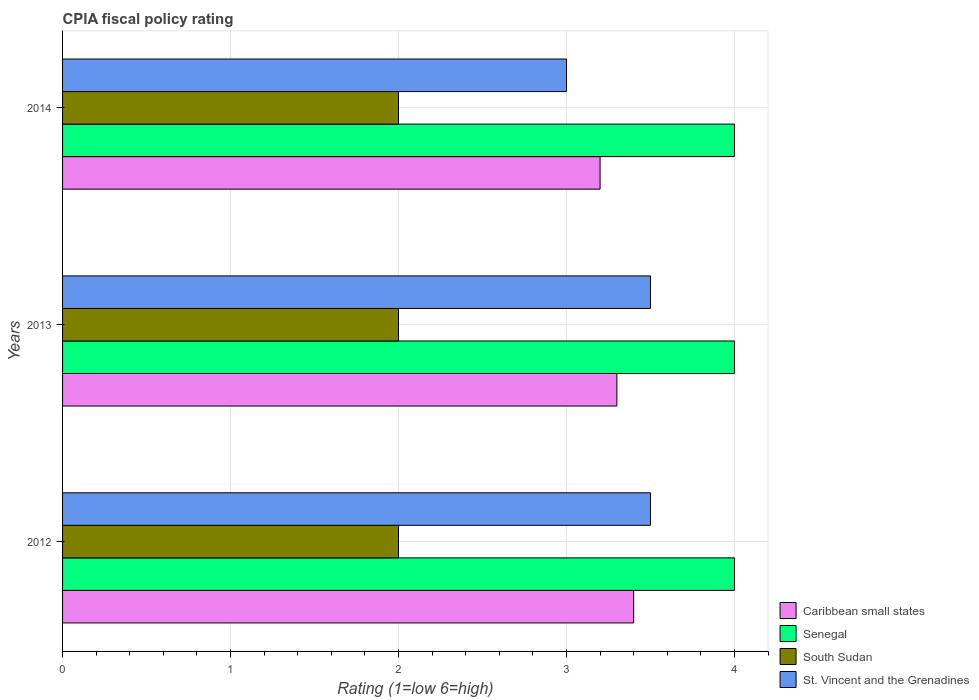Are the number of bars on each tick of the Y-axis equal?
Offer a terse response. Yes. What is the CPIA rating in St. Vincent and the Grenadines in 2013?
Your answer should be very brief. 3.5. Across all years, what is the minimum CPIA rating in St. Vincent and the Grenadines?
Your response must be concise. 3. In which year was the CPIA rating in St. Vincent and the Grenadines minimum?
Keep it short and to the point. 2014. What is the total CPIA rating in Caribbean small states in the graph?
Ensure brevity in your answer.  9.9. What is the difference between the CPIA rating in South Sudan in 2012 and that in 2013?
Offer a very short reply. 0. What is the average CPIA rating in Caribbean small states per year?
Give a very brief answer. 3.3. In the year 2014, what is the difference between the CPIA rating in Senegal and CPIA rating in Caribbean small states?
Make the answer very short. 0.8. In how many years, is the CPIA rating in Caribbean small states greater than 1.6 ?
Offer a terse response. 3. What is the difference between the highest and the second highest CPIA rating in South Sudan?
Give a very brief answer. 0. What is the difference between the highest and the lowest CPIA rating in St. Vincent and the Grenadines?
Keep it short and to the point. 0.5. In how many years, is the CPIA rating in Caribbean small states greater than the average CPIA rating in Caribbean small states taken over all years?
Make the answer very short. 2. Is the sum of the CPIA rating in St. Vincent and the Grenadines in 2012 and 2014 greater than the maximum CPIA rating in Caribbean small states across all years?
Your answer should be very brief. Yes. Is it the case that in every year, the sum of the CPIA rating in St. Vincent and the Grenadines and CPIA rating in Caribbean small states is greater than the sum of CPIA rating in South Sudan and CPIA rating in Senegal?
Make the answer very short. No. What does the 1st bar from the top in 2012 represents?
Give a very brief answer. St. Vincent and the Grenadines. What does the 4th bar from the bottom in 2013 represents?
Your response must be concise. St. Vincent and the Grenadines. How many bars are there?
Offer a terse response. 12. How many years are there in the graph?
Give a very brief answer. 3. Are the values on the major ticks of X-axis written in scientific E-notation?
Your answer should be compact. No. What is the title of the graph?
Your answer should be very brief. CPIA fiscal policy rating. Does "Cyprus" appear as one of the legend labels in the graph?
Keep it short and to the point. No. What is the label or title of the X-axis?
Make the answer very short. Rating (1=low 6=high). What is the Rating (1=low 6=high) of South Sudan in 2012?
Offer a very short reply. 2. What is the Rating (1=low 6=high) in St. Vincent and the Grenadines in 2012?
Keep it short and to the point. 3.5. What is the Rating (1=low 6=high) in Caribbean small states in 2013?
Your response must be concise. 3.3. What is the Rating (1=low 6=high) in Senegal in 2013?
Give a very brief answer. 4. What is the Rating (1=low 6=high) in South Sudan in 2013?
Your response must be concise. 2. Across all years, what is the maximum Rating (1=low 6=high) in Senegal?
Give a very brief answer. 4. Across all years, what is the maximum Rating (1=low 6=high) of St. Vincent and the Grenadines?
Your answer should be compact. 3.5. Across all years, what is the minimum Rating (1=low 6=high) of Senegal?
Give a very brief answer. 4. Across all years, what is the minimum Rating (1=low 6=high) in South Sudan?
Ensure brevity in your answer.  2. What is the total Rating (1=low 6=high) of Caribbean small states in the graph?
Make the answer very short. 9.9. What is the difference between the Rating (1=low 6=high) of St. Vincent and the Grenadines in 2012 and that in 2013?
Your response must be concise. 0. What is the difference between the Rating (1=low 6=high) of Caribbean small states in 2012 and that in 2014?
Your answer should be compact. 0.2. What is the difference between the Rating (1=low 6=high) of Senegal in 2012 and that in 2014?
Ensure brevity in your answer.  0. What is the difference between the Rating (1=low 6=high) in Caribbean small states in 2013 and that in 2014?
Your answer should be compact. 0.1. What is the difference between the Rating (1=low 6=high) of Senegal in 2013 and that in 2014?
Keep it short and to the point. 0. What is the difference between the Rating (1=low 6=high) in South Sudan in 2013 and that in 2014?
Ensure brevity in your answer.  0. What is the difference between the Rating (1=low 6=high) in St. Vincent and the Grenadines in 2013 and that in 2014?
Provide a succinct answer. 0.5. What is the difference between the Rating (1=low 6=high) in Caribbean small states in 2012 and the Rating (1=low 6=high) in South Sudan in 2013?
Ensure brevity in your answer.  1.4. What is the difference between the Rating (1=low 6=high) in Caribbean small states in 2012 and the Rating (1=low 6=high) in St. Vincent and the Grenadines in 2013?
Offer a terse response. -0.1. What is the difference between the Rating (1=low 6=high) in Senegal in 2012 and the Rating (1=low 6=high) in South Sudan in 2013?
Provide a succinct answer. 2. What is the difference between the Rating (1=low 6=high) of South Sudan in 2012 and the Rating (1=low 6=high) of St. Vincent and the Grenadines in 2013?
Give a very brief answer. -1.5. What is the difference between the Rating (1=low 6=high) in Caribbean small states in 2012 and the Rating (1=low 6=high) in Senegal in 2014?
Offer a terse response. -0.6. What is the difference between the Rating (1=low 6=high) in Senegal in 2012 and the Rating (1=low 6=high) in South Sudan in 2014?
Provide a succinct answer. 2. What is the difference between the Rating (1=low 6=high) in Caribbean small states in 2013 and the Rating (1=low 6=high) in St. Vincent and the Grenadines in 2014?
Keep it short and to the point. 0.3. What is the difference between the Rating (1=low 6=high) in Senegal in 2013 and the Rating (1=low 6=high) in South Sudan in 2014?
Provide a short and direct response. 2. What is the average Rating (1=low 6=high) of Caribbean small states per year?
Your answer should be compact. 3.3. What is the average Rating (1=low 6=high) in Senegal per year?
Make the answer very short. 4. What is the average Rating (1=low 6=high) in South Sudan per year?
Provide a succinct answer. 2. What is the average Rating (1=low 6=high) of St. Vincent and the Grenadines per year?
Your answer should be compact. 3.33. In the year 2012, what is the difference between the Rating (1=low 6=high) of Caribbean small states and Rating (1=low 6=high) of Senegal?
Offer a very short reply. -0.6. In the year 2012, what is the difference between the Rating (1=low 6=high) in Caribbean small states and Rating (1=low 6=high) in South Sudan?
Give a very brief answer. 1.4. In the year 2012, what is the difference between the Rating (1=low 6=high) in Senegal and Rating (1=low 6=high) in South Sudan?
Offer a terse response. 2. In the year 2012, what is the difference between the Rating (1=low 6=high) in Senegal and Rating (1=low 6=high) in St. Vincent and the Grenadines?
Provide a short and direct response. 0.5. In the year 2013, what is the difference between the Rating (1=low 6=high) in Senegal and Rating (1=low 6=high) in South Sudan?
Offer a terse response. 2. In the year 2013, what is the difference between the Rating (1=low 6=high) of South Sudan and Rating (1=low 6=high) of St. Vincent and the Grenadines?
Make the answer very short. -1.5. In the year 2014, what is the difference between the Rating (1=low 6=high) in Caribbean small states and Rating (1=low 6=high) in South Sudan?
Your answer should be compact. 1.2. In the year 2014, what is the difference between the Rating (1=low 6=high) of Caribbean small states and Rating (1=low 6=high) of St. Vincent and the Grenadines?
Provide a succinct answer. 0.2. In the year 2014, what is the difference between the Rating (1=low 6=high) of Senegal and Rating (1=low 6=high) of St. Vincent and the Grenadines?
Offer a terse response. 1. In the year 2014, what is the difference between the Rating (1=low 6=high) in South Sudan and Rating (1=low 6=high) in St. Vincent and the Grenadines?
Offer a very short reply. -1. What is the ratio of the Rating (1=low 6=high) in Caribbean small states in 2012 to that in 2013?
Offer a terse response. 1.03. What is the ratio of the Rating (1=low 6=high) in South Sudan in 2012 to that in 2013?
Offer a very short reply. 1. What is the ratio of the Rating (1=low 6=high) in Senegal in 2012 to that in 2014?
Make the answer very short. 1. What is the ratio of the Rating (1=low 6=high) of South Sudan in 2012 to that in 2014?
Your response must be concise. 1. What is the ratio of the Rating (1=low 6=high) in St. Vincent and the Grenadines in 2012 to that in 2014?
Keep it short and to the point. 1.17. What is the ratio of the Rating (1=low 6=high) of Caribbean small states in 2013 to that in 2014?
Your response must be concise. 1.03. What is the ratio of the Rating (1=low 6=high) in Senegal in 2013 to that in 2014?
Your answer should be compact. 1. What is the ratio of the Rating (1=low 6=high) in St. Vincent and the Grenadines in 2013 to that in 2014?
Ensure brevity in your answer.  1.17. What is the difference between the highest and the second highest Rating (1=low 6=high) of South Sudan?
Provide a succinct answer. 0. What is the difference between the highest and the second highest Rating (1=low 6=high) of St. Vincent and the Grenadines?
Provide a short and direct response. 0. What is the difference between the highest and the lowest Rating (1=low 6=high) in Caribbean small states?
Your response must be concise. 0.2. What is the difference between the highest and the lowest Rating (1=low 6=high) of South Sudan?
Your answer should be very brief. 0. What is the difference between the highest and the lowest Rating (1=low 6=high) of St. Vincent and the Grenadines?
Ensure brevity in your answer.  0.5. 